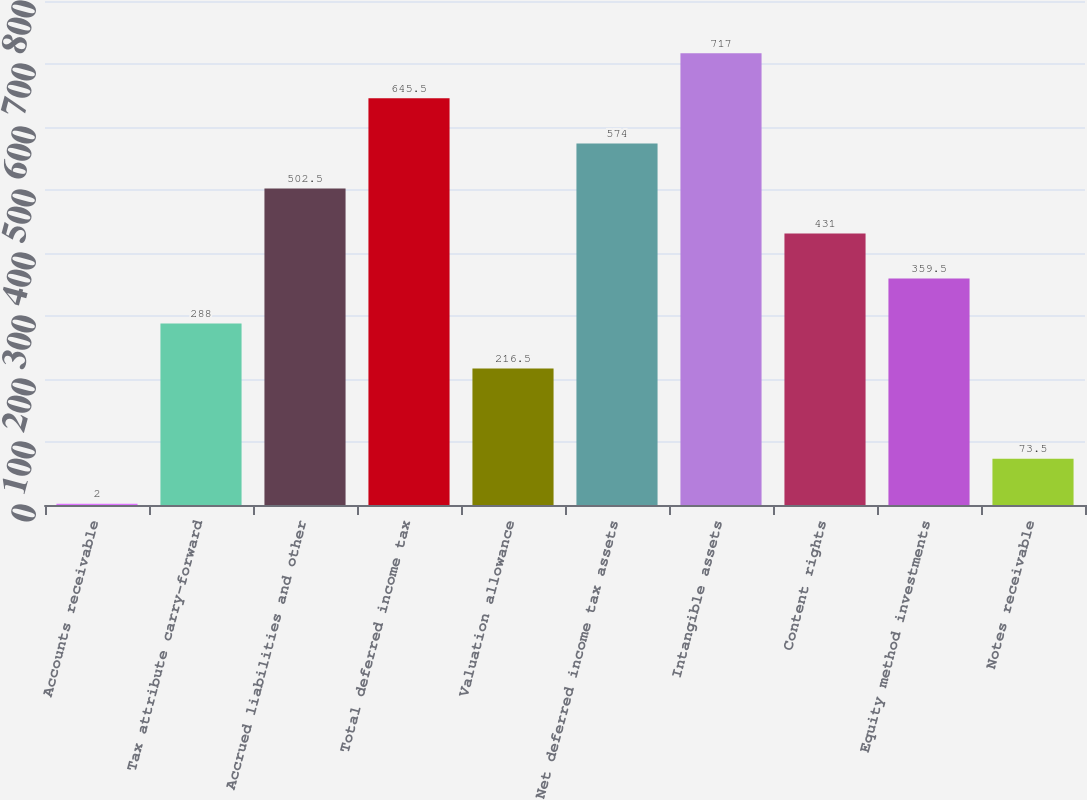<chart> <loc_0><loc_0><loc_500><loc_500><bar_chart><fcel>Accounts receivable<fcel>Tax attribute carry-forward<fcel>Accrued liabilities and other<fcel>Total deferred income tax<fcel>Valuation allowance<fcel>Net deferred income tax assets<fcel>Intangible assets<fcel>Content rights<fcel>Equity method investments<fcel>Notes receivable<nl><fcel>2<fcel>288<fcel>502.5<fcel>645.5<fcel>216.5<fcel>574<fcel>717<fcel>431<fcel>359.5<fcel>73.5<nl></chart> 